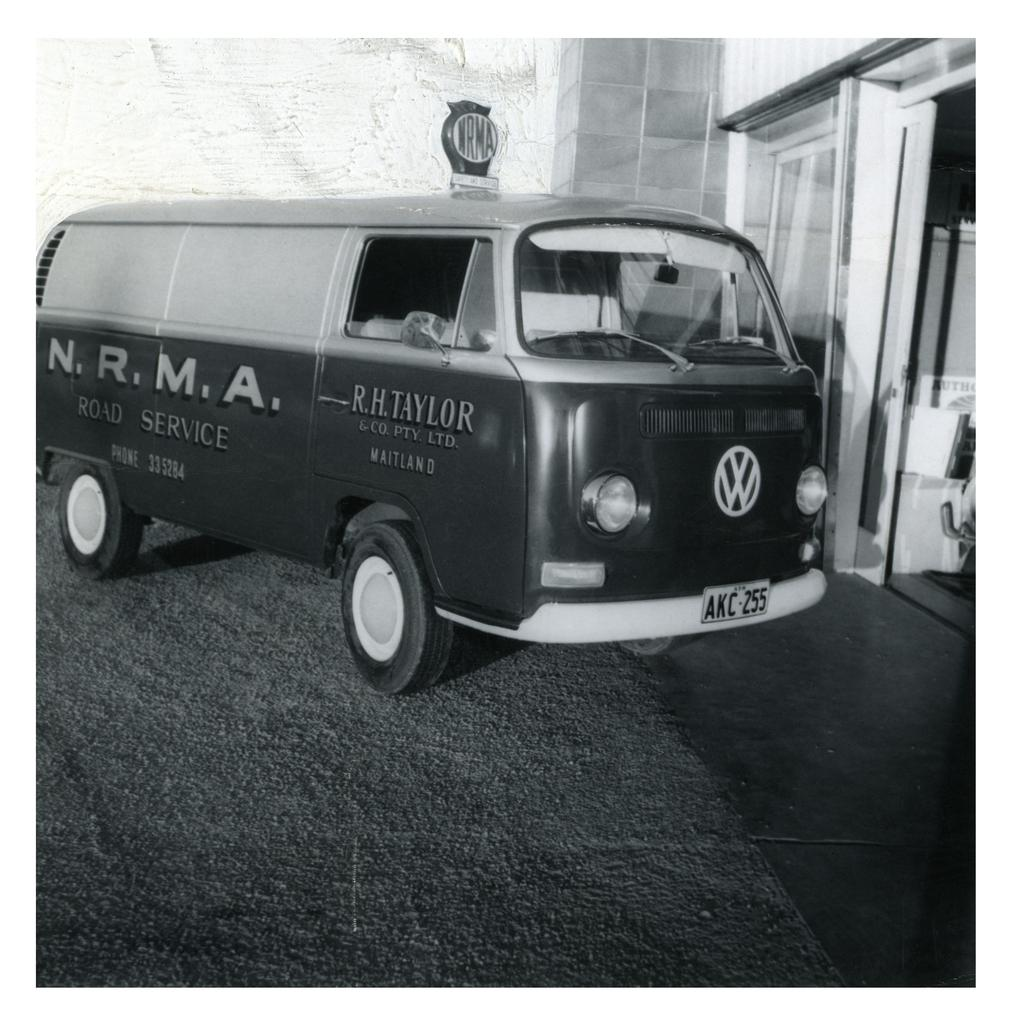<image>
Share a concise interpretation of the image provided. A VW van has NRMA road service printed on the side. 